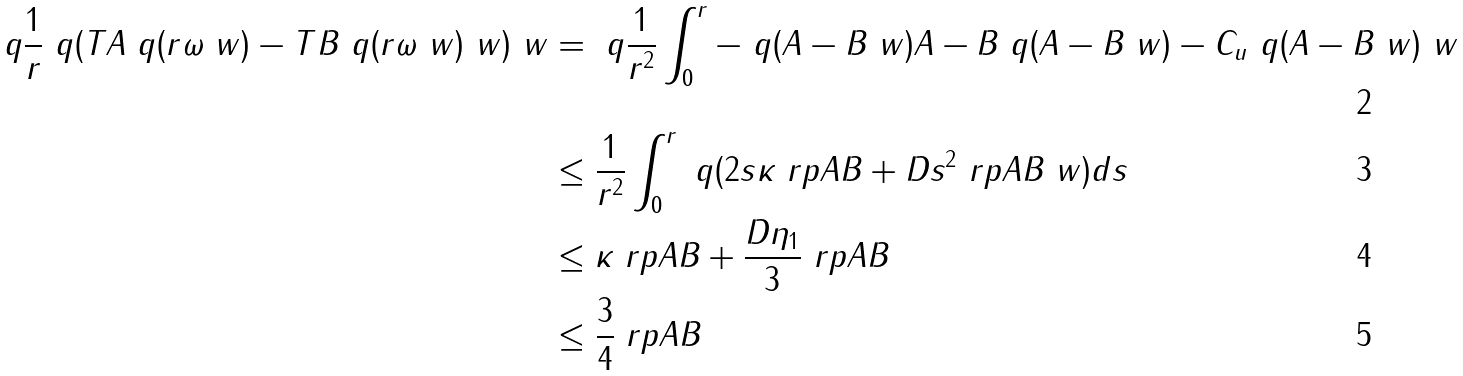<formula> <loc_0><loc_0><loc_500><loc_500>\ q \| \frac { 1 } { r } \ q ( T A \ q ( r \omega \ w ) - T B \ q ( r \omega \ w ) \ w ) \ w \| & = \ q \| \frac { 1 } { r ^ { 2 } } \int _ { 0 } ^ { r } - \ q ( A - B \ w ) A - B \ q ( A - B \ w ) - C _ { u } \ q ( A - B \ w ) \ w \| \\ & \leq \frac { 1 } { r ^ { 2 } } \int _ { 0 } ^ { r } \ q ( 2 s \kappa \ r p { A } { B } + D s ^ { 2 } \ r p { A } { B } \ w ) d s \\ & \leq \kappa \ r p { A } { B } + \frac { D \eta _ { 1 } } { 3 } \ r p { A } { B } \\ & \leq \frac { 3 } { 4 } \ r p { A } { B }</formula> 